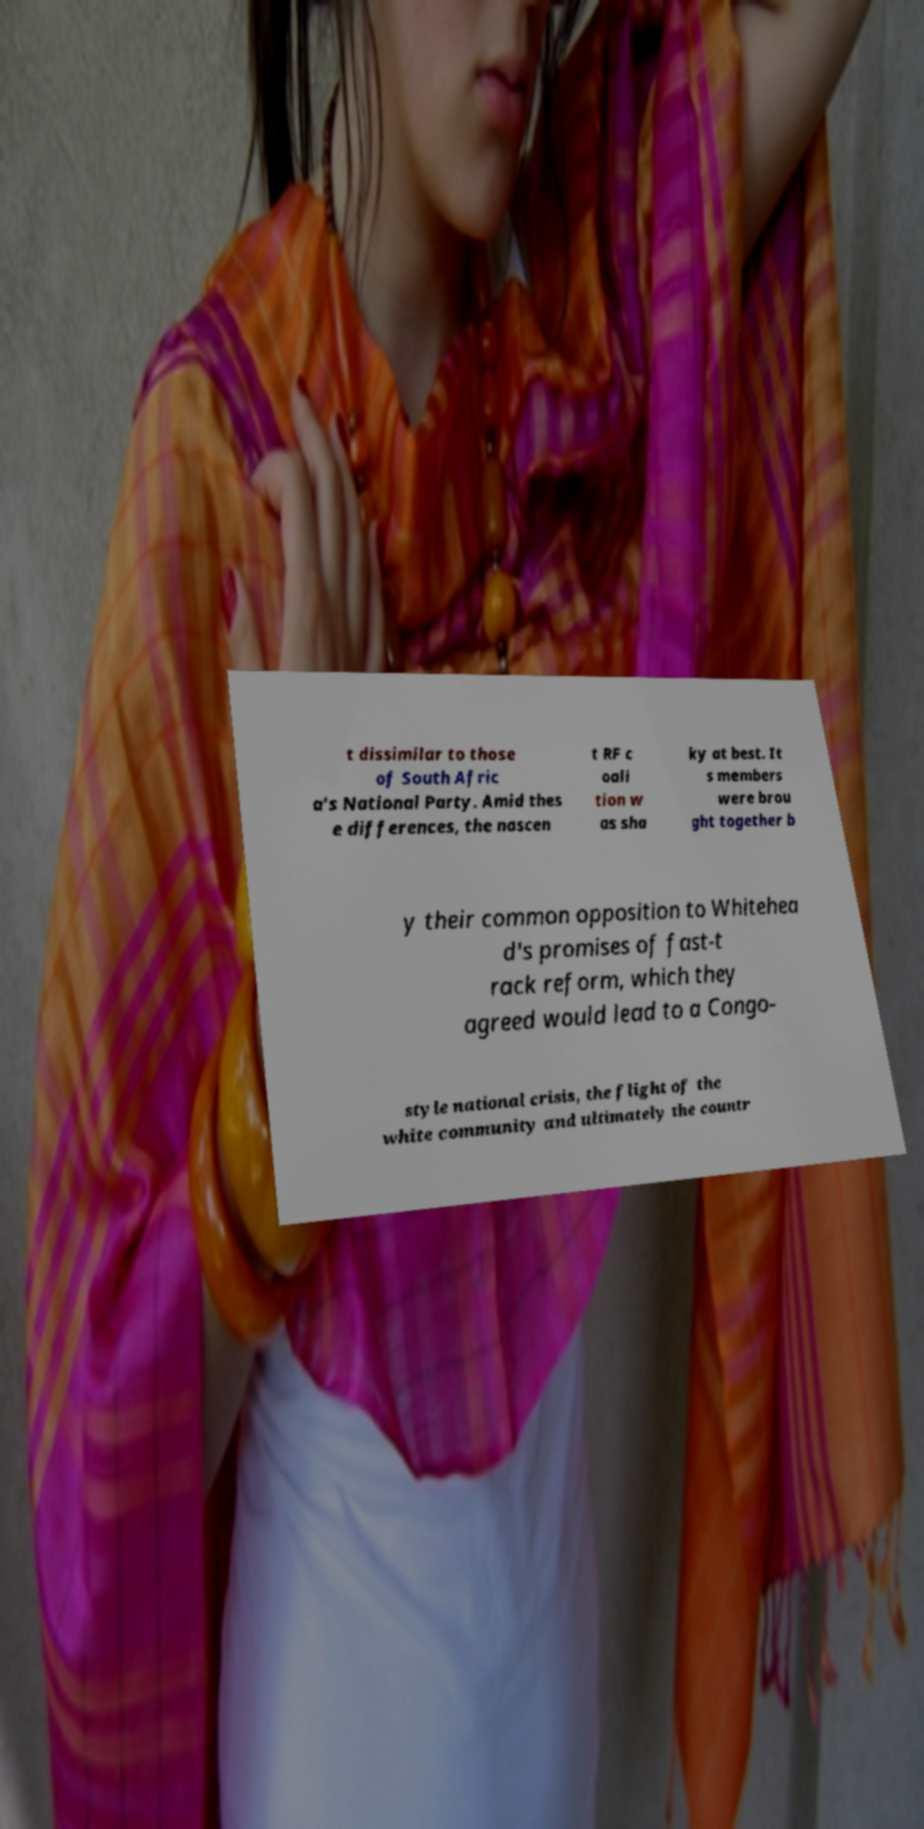What messages or text are displayed in this image? I need them in a readable, typed format. t dissimilar to those of South Afric a's National Party. Amid thes e differences, the nascen t RF c oali tion w as sha ky at best. It s members were brou ght together b y their common opposition to Whitehea d's promises of fast-t rack reform, which they agreed would lead to a Congo- style national crisis, the flight of the white community and ultimately the countr 